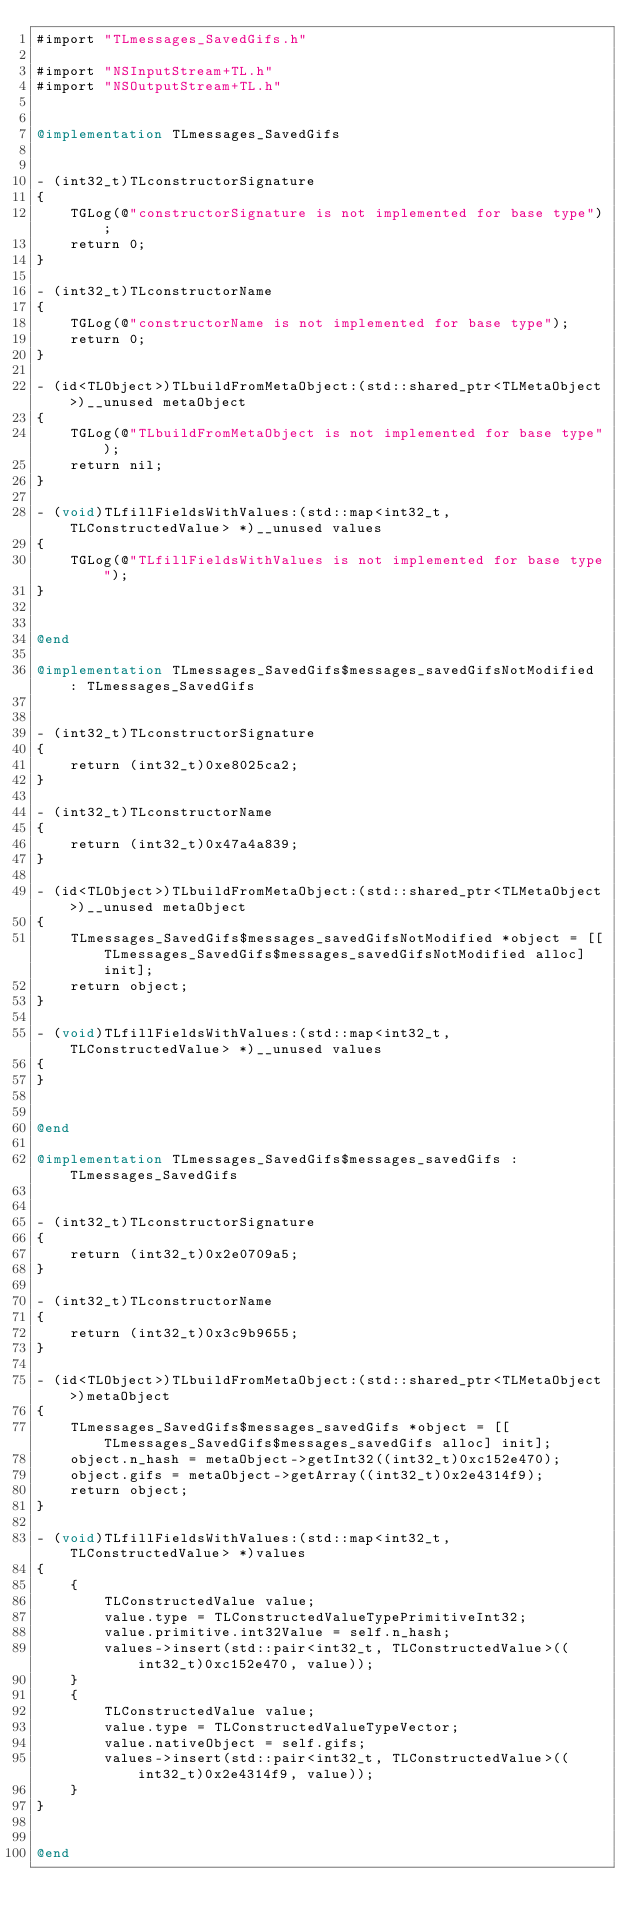<code> <loc_0><loc_0><loc_500><loc_500><_ObjectiveC_>#import "TLmessages_SavedGifs.h"

#import "NSInputStream+TL.h"
#import "NSOutputStream+TL.h"


@implementation TLmessages_SavedGifs


- (int32_t)TLconstructorSignature
{
    TGLog(@"constructorSignature is not implemented for base type");
    return 0;
}

- (int32_t)TLconstructorName
{
    TGLog(@"constructorName is not implemented for base type");
    return 0;
}

- (id<TLObject>)TLbuildFromMetaObject:(std::shared_ptr<TLMetaObject>)__unused metaObject
{
    TGLog(@"TLbuildFromMetaObject is not implemented for base type");
    return nil;
}

- (void)TLfillFieldsWithValues:(std::map<int32_t, TLConstructedValue> *)__unused values
{
    TGLog(@"TLfillFieldsWithValues is not implemented for base type");
}


@end

@implementation TLmessages_SavedGifs$messages_savedGifsNotModified : TLmessages_SavedGifs


- (int32_t)TLconstructorSignature
{
    return (int32_t)0xe8025ca2;
}

- (int32_t)TLconstructorName
{
    return (int32_t)0x47a4a839;
}

- (id<TLObject>)TLbuildFromMetaObject:(std::shared_ptr<TLMetaObject>)__unused metaObject
{
    TLmessages_SavedGifs$messages_savedGifsNotModified *object = [[TLmessages_SavedGifs$messages_savedGifsNotModified alloc] init];
    return object;
}

- (void)TLfillFieldsWithValues:(std::map<int32_t, TLConstructedValue> *)__unused values
{
}


@end

@implementation TLmessages_SavedGifs$messages_savedGifs : TLmessages_SavedGifs


- (int32_t)TLconstructorSignature
{
    return (int32_t)0x2e0709a5;
}

- (int32_t)TLconstructorName
{
    return (int32_t)0x3c9b9655;
}

- (id<TLObject>)TLbuildFromMetaObject:(std::shared_ptr<TLMetaObject>)metaObject
{
    TLmessages_SavedGifs$messages_savedGifs *object = [[TLmessages_SavedGifs$messages_savedGifs alloc] init];
    object.n_hash = metaObject->getInt32((int32_t)0xc152e470);
    object.gifs = metaObject->getArray((int32_t)0x2e4314f9);
    return object;
}

- (void)TLfillFieldsWithValues:(std::map<int32_t, TLConstructedValue> *)values
{
    {
        TLConstructedValue value;
        value.type = TLConstructedValueTypePrimitiveInt32;
        value.primitive.int32Value = self.n_hash;
        values->insert(std::pair<int32_t, TLConstructedValue>((int32_t)0xc152e470, value));
    }
    {
        TLConstructedValue value;
        value.type = TLConstructedValueTypeVector;
        value.nativeObject = self.gifs;
        values->insert(std::pair<int32_t, TLConstructedValue>((int32_t)0x2e4314f9, value));
    }
}


@end

</code> 